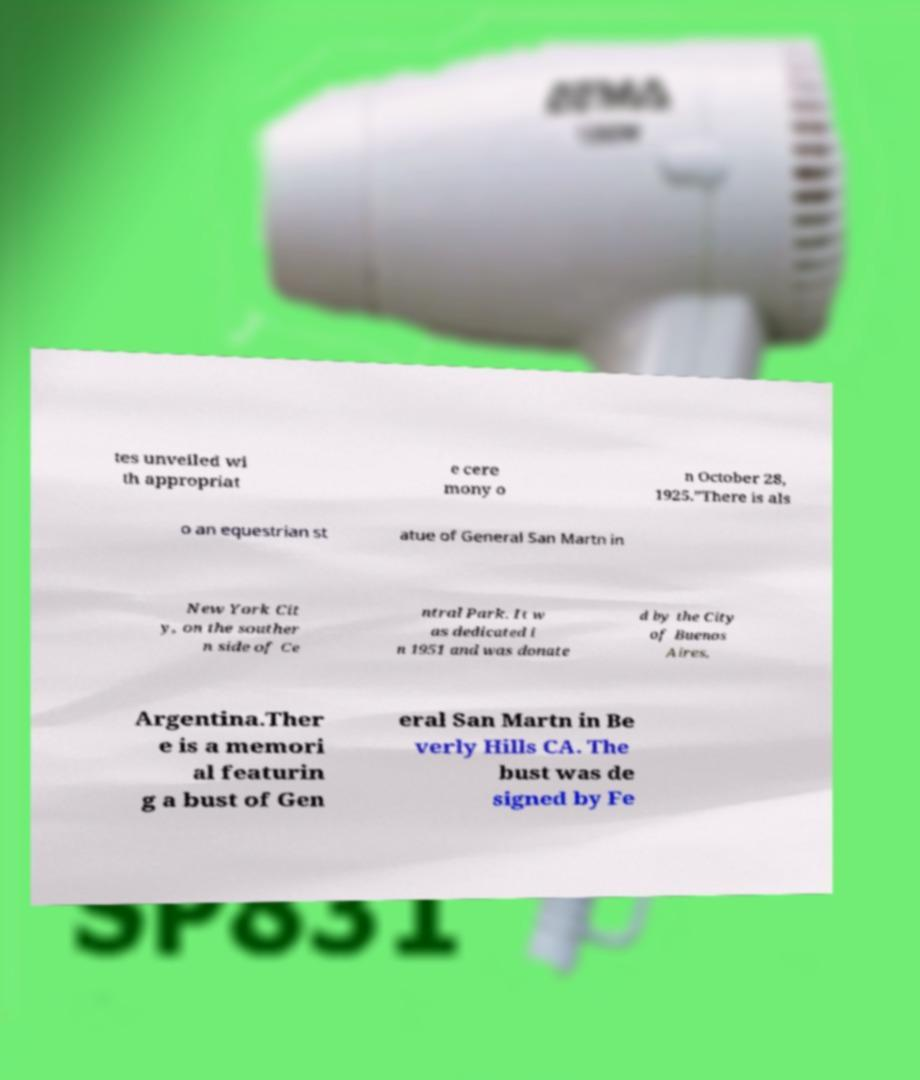What messages or text are displayed in this image? I need them in a readable, typed format. tes unveiled wi th appropriat e cere mony o n October 28, 1925.”There is als o an equestrian st atue of General San Martn in New York Cit y, on the souther n side of Ce ntral Park. It w as dedicated i n 1951 and was donate d by the City of Buenos Aires, Argentina.Ther e is a memori al featurin g a bust of Gen eral San Martn in Be verly Hills CA. The bust was de signed by Fe 